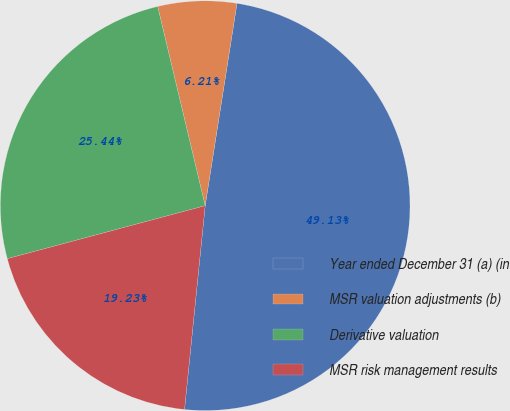<chart> <loc_0><loc_0><loc_500><loc_500><pie_chart><fcel>Year ended December 31 (a) (in<fcel>MSR valuation adjustments (b)<fcel>Derivative valuation<fcel>MSR risk management results<nl><fcel>49.13%<fcel>6.21%<fcel>25.44%<fcel>19.23%<nl></chart> 